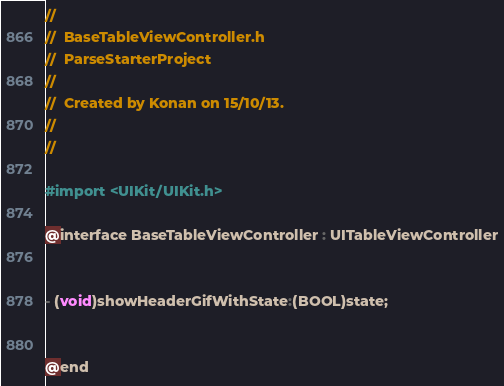<code> <loc_0><loc_0><loc_500><loc_500><_C_>//
//  BaseTableViewController.h
//  ParseStarterProject
//
//  Created by Konan on 15/10/13.
//
//

#import <UIKit/UIKit.h>

@interface BaseTableViewController : UITableViewController


- (void)showHeaderGifWithState:(BOOL)state;


@end
</code> 